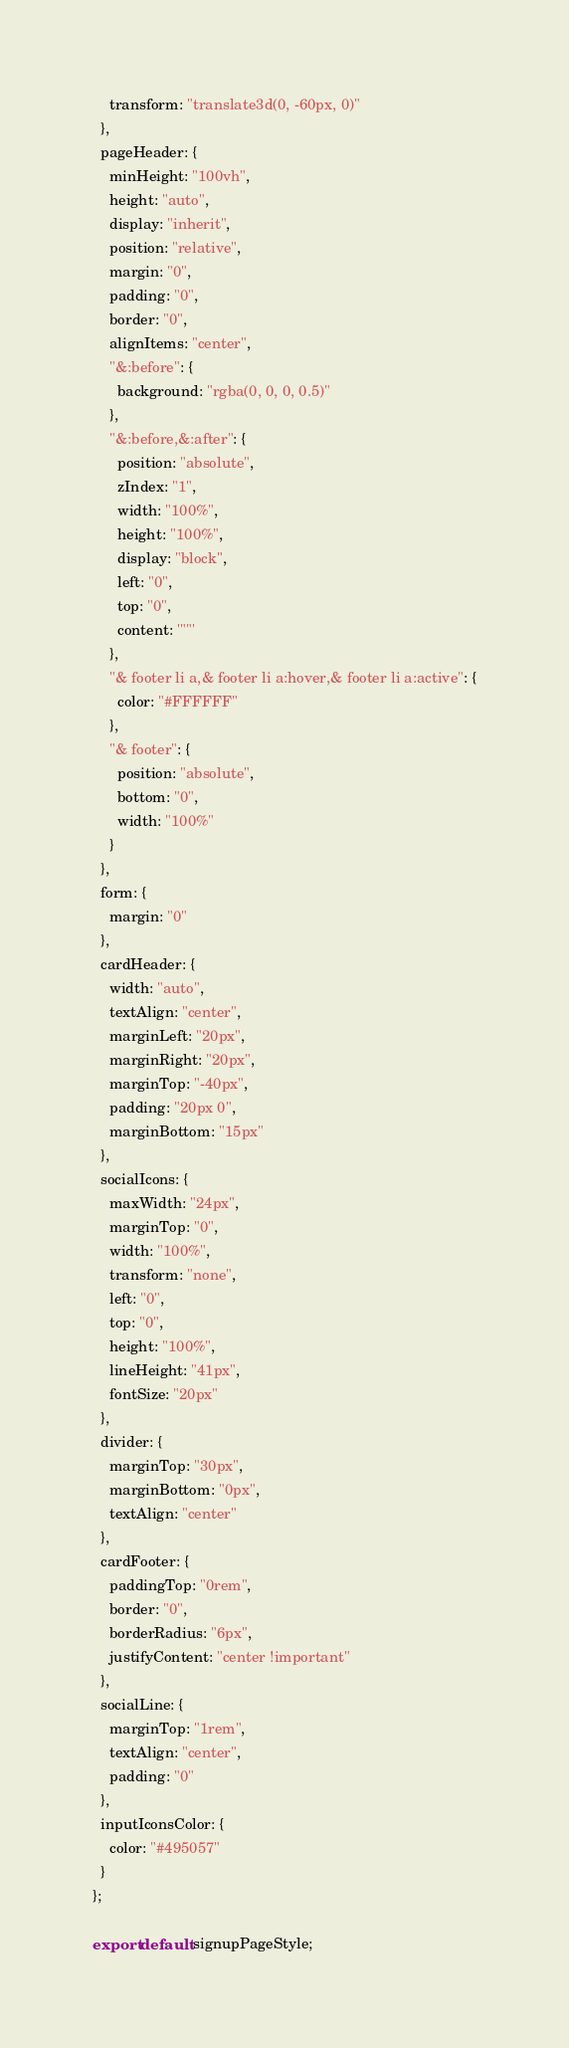<code> <loc_0><loc_0><loc_500><loc_500><_JavaScript_>    transform: "translate3d(0, -60px, 0)"
  },
  pageHeader: {
    minHeight: "100vh",
    height: "auto",
    display: "inherit",
    position: "relative",
    margin: "0",
    padding: "0",
    border: "0",
    alignItems: "center",
    "&:before": {
      background: "rgba(0, 0, 0, 0.5)"
    },
    "&:before,&:after": {
      position: "absolute",
      zIndex: "1",
      width: "100%",
      height: "100%",
      display: "block",
      left: "0",
      top: "0",
      content: '""'
    },
    "& footer li a,& footer li a:hover,& footer li a:active": {
      color: "#FFFFFF"
    },
    "& footer": {
      position: "absolute",
      bottom: "0",
      width: "100%"
    }
  },
  form: {
    margin: "0"
  },
  cardHeader: {
    width: "auto",
    textAlign: "center",
    marginLeft: "20px",
    marginRight: "20px",
    marginTop: "-40px",
    padding: "20px 0",
    marginBottom: "15px"
  },
  socialIcons: {
    maxWidth: "24px",
    marginTop: "0",
    width: "100%",
    transform: "none",
    left: "0",
    top: "0",
    height: "100%",
    lineHeight: "41px",
    fontSize: "20px"
  },
  divider: {
    marginTop: "30px",
    marginBottom: "0px",
    textAlign: "center"
  },
  cardFooter: {
    paddingTop: "0rem",
    border: "0",
    borderRadius: "6px",
    justifyContent: "center !important"
  },
  socialLine: {
    marginTop: "1rem",
    textAlign: "center",
    padding: "0"
  },
  inputIconsColor: {
    color: "#495057"
  }
};

export default signupPageStyle;
</code> 